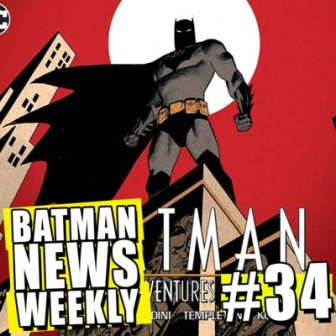Analyze the image in a comprehensive and detailed manner. The image displays an eye-catching comic book cover starring the legendary superhero, Batman. Dominated by a vivid red background, the cover provides a dramatic contrast to the dark and imposing silhouette of Batman, who is portrayed standing atop a building. The building is vividly colored in yellow tones with black outlines, emphasizing the dynamic and bold style of the illustration.

Front and center, Batman's stance is both powerful and commanding, creating an image of strength and vigilance. Surrounding Batman, the text is presented in a distinctive comic book font, primarily in white and black, and announces 'Batman News Weekly' and 'Batman Adventures #34', indicating the series title and issue number. The names 'DINI TEMPLETON KLAUS' are also present, suggesting the creators or key contributors to this particular issue.

The composition of the cover is thoughtfully executed, with Batman placed centrally, drawing immediate attention, while the building beneath him reinforces his dominant position. The placement of the text is strategic, ensuring it's readable without overshadowing the powerful visual of Batman. Overall, the cover's balanced arrangement ingeniously captures the viewer's attention to both the superhero's formidable presence and the relevant textual details. 